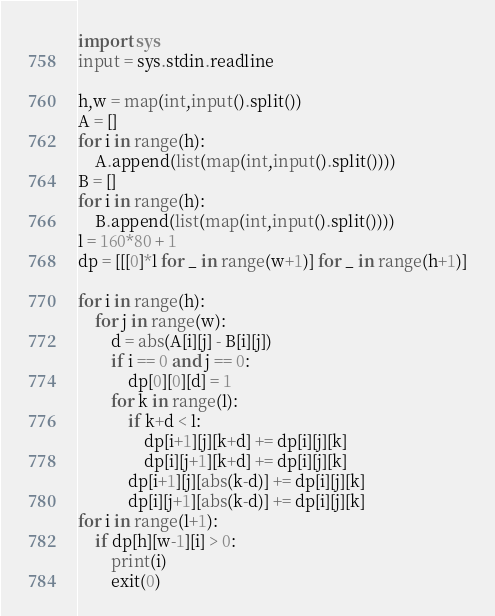<code> <loc_0><loc_0><loc_500><loc_500><_Python_>import sys
input = sys.stdin.readline

h,w = map(int,input().split())
A = []
for i in range(h):
    A.append(list(map(int,input().split())))
B = []
for i in range(h):
    B.append(list(map(int,input().split())))
l = 160*80 + 1
dp = [[[0]*l for _ in range(w+1)] for _ in range(h+1)]

for i in range(h):
    for j in range(w):
        d = abs(A[i][j] - B[i][j])
        if i == 0 and j == 0:
            dp[0][0][d] = 1
        for k in range(l):
            if k+d < l:
                dp[i+1][j][k+d] += dp[i][j][k]
                dp[i][j+1][k+d] += dp[i][j][k]
            dp[i+1][j][abs(k-d)] += dp[i][j][k]
            dp[i][j+1][abs(k-d)] += dp[i][j][k]
for i in range(l+1):
    if dp[h][w-1][i] > 0:
        print(i)
        exit(0)
</code> 